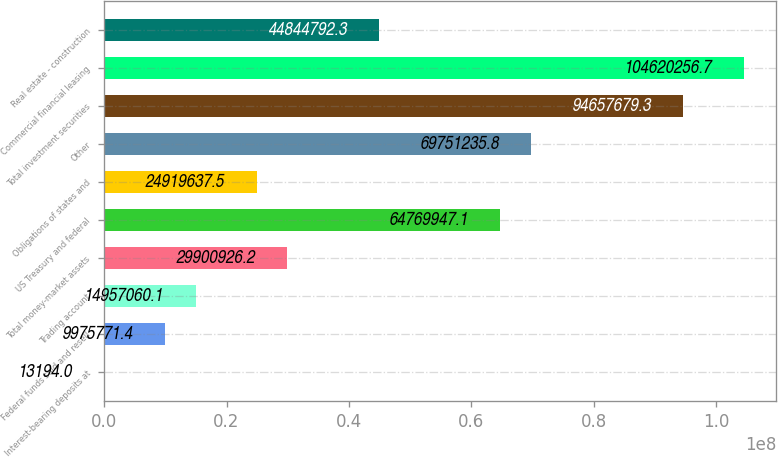Convert chart to OTSL. <chart><loc_0><loc_0><loc_500><loc_500><bar_chart><fcel>Interest-bearing deposits at<fcel>Federal funds sold and resell<fcel>Trading account<fcel>Total money-market assets<fcel>US Treasury and federal<fcel>Obligations of states and<fcel>Other<fcel>Total investment securities<fcel>Commercial financial leasing<fcel>Real estate - construction<nl><fcel>13194<fcel>9.97577e+06<fcel>1.49571e+07<fcel>2.99009e+07<fcel>6.47699e+07<fcel>2.49196e+07<fcel>6.97512e+07<fcel>9.46577e+07<fcel>1.0462e+08<fcel>4.48448e+07<nl></chart> 